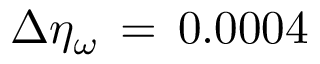<formula> <loc_0><loc_0><loc_500><loc_500>\Delta \eta _ { \omega } \, = \, 0 . 0 0 0 4</formula> 